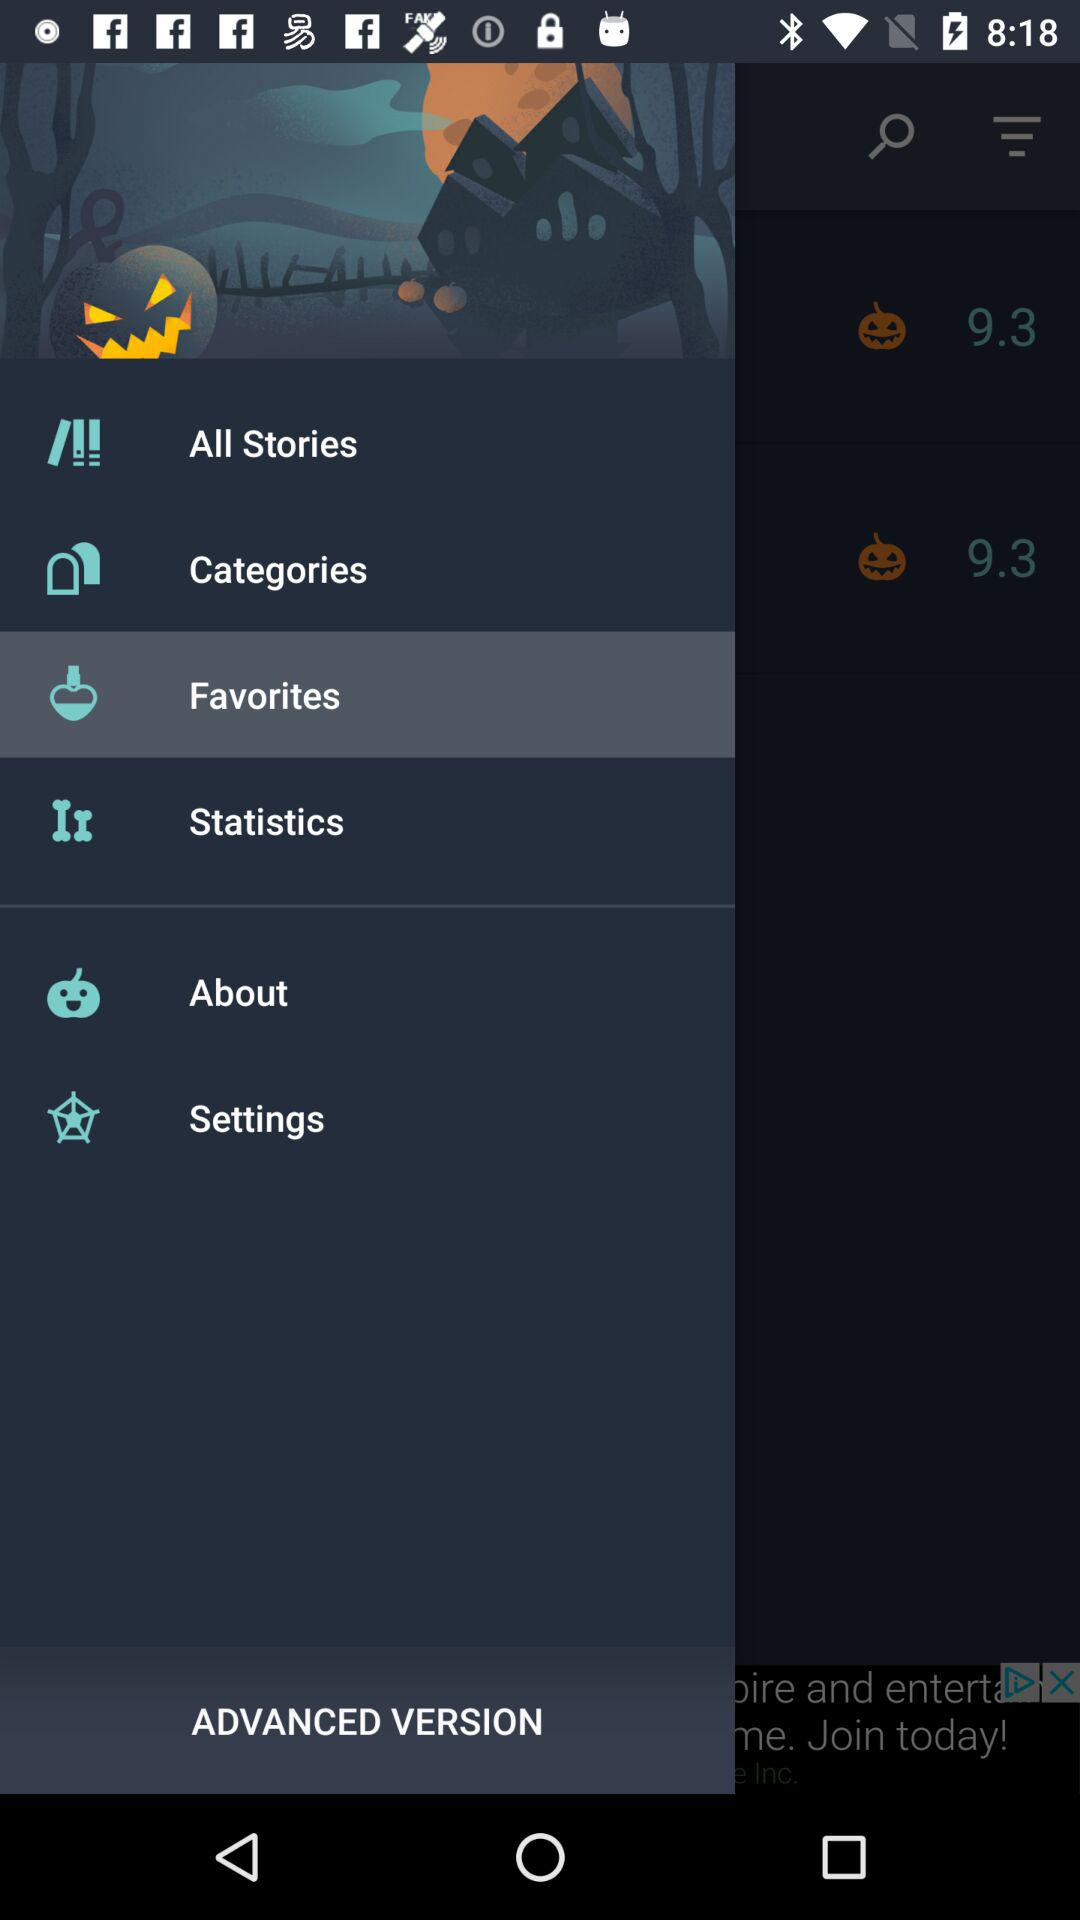What is the average rating of the app?
Answer the question using a single word or phrase. 9.3 